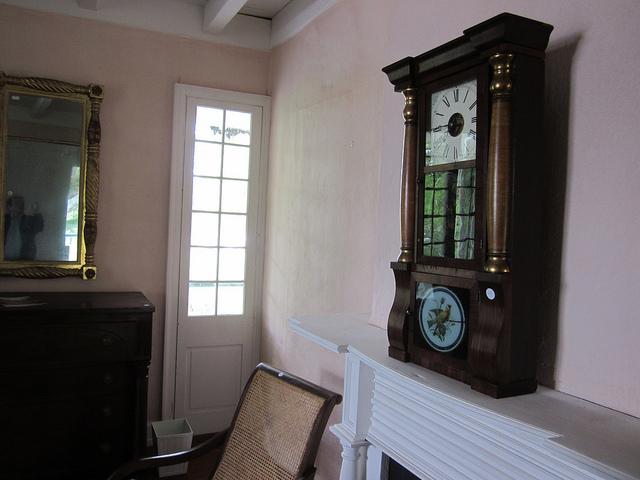Is there a mirror on the wall?
Concise answer only. Yes. What color are the walls?
Give a very brief answer. Pink. What time is it?
Concise answer only. 8:45. Is the door open?
Give a very brief answer. No. Is there a fireplace?
Quick response, please. Yes. 